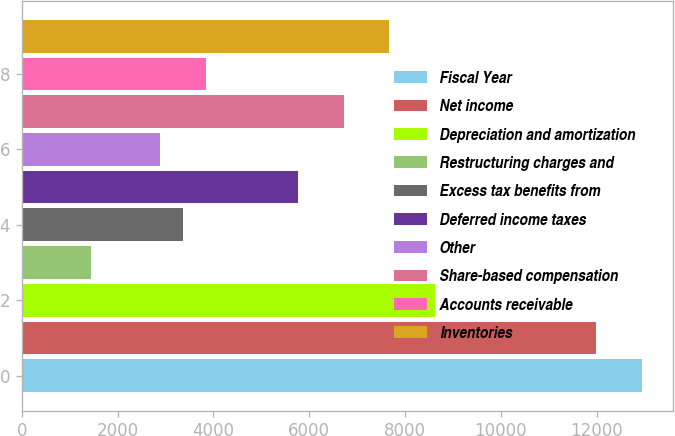Convert chart. <chart><loc_0><loc_0><loc_500><loc_500><bar_chart><fcel>Fiscal Year<fcel>Net income<fcel>Depreciation and amortization<fcel>Restructuring charges and<fcel>Excess tax benefits from<fcel>Deferred income taxes<fcel>Other<fcel>Share-based compensation<fcel>Accounts receivable<fcel>Inventories<nl><fcel>12948.5<fcel>11989.5<fcel>8633<fcel>1440.5<fcel>3358.5<fcel>5756<fcel>2879<fcel>6715<fcel>3838<fcel>7674<nl></chart> 